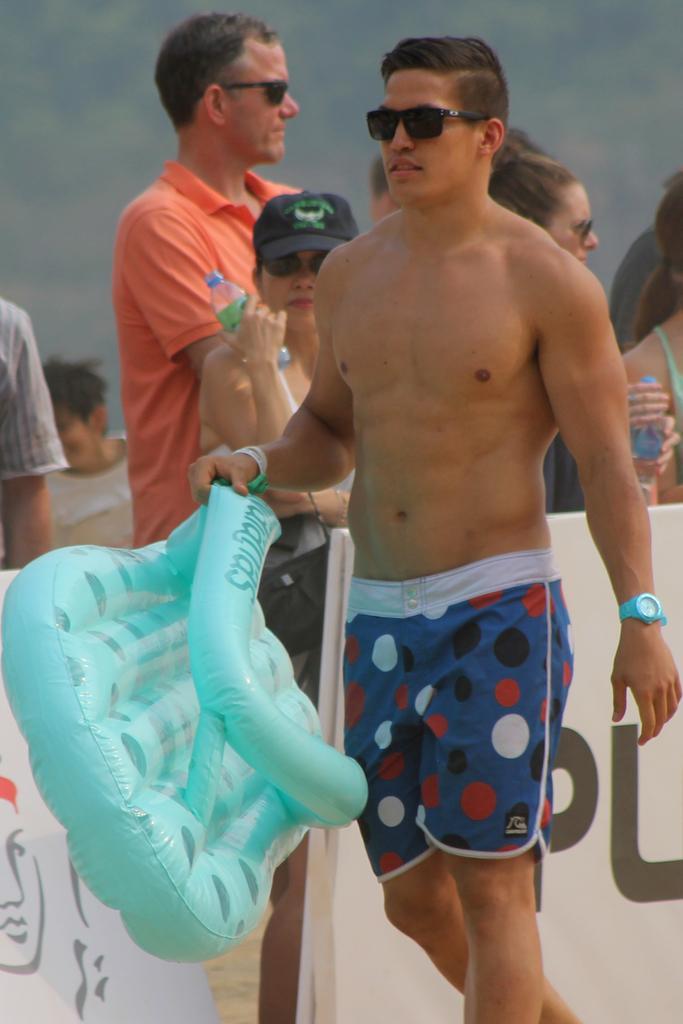Describe this image in one or two sentences. In the image i can see a person who is holding the tube and behind there are some other people. 